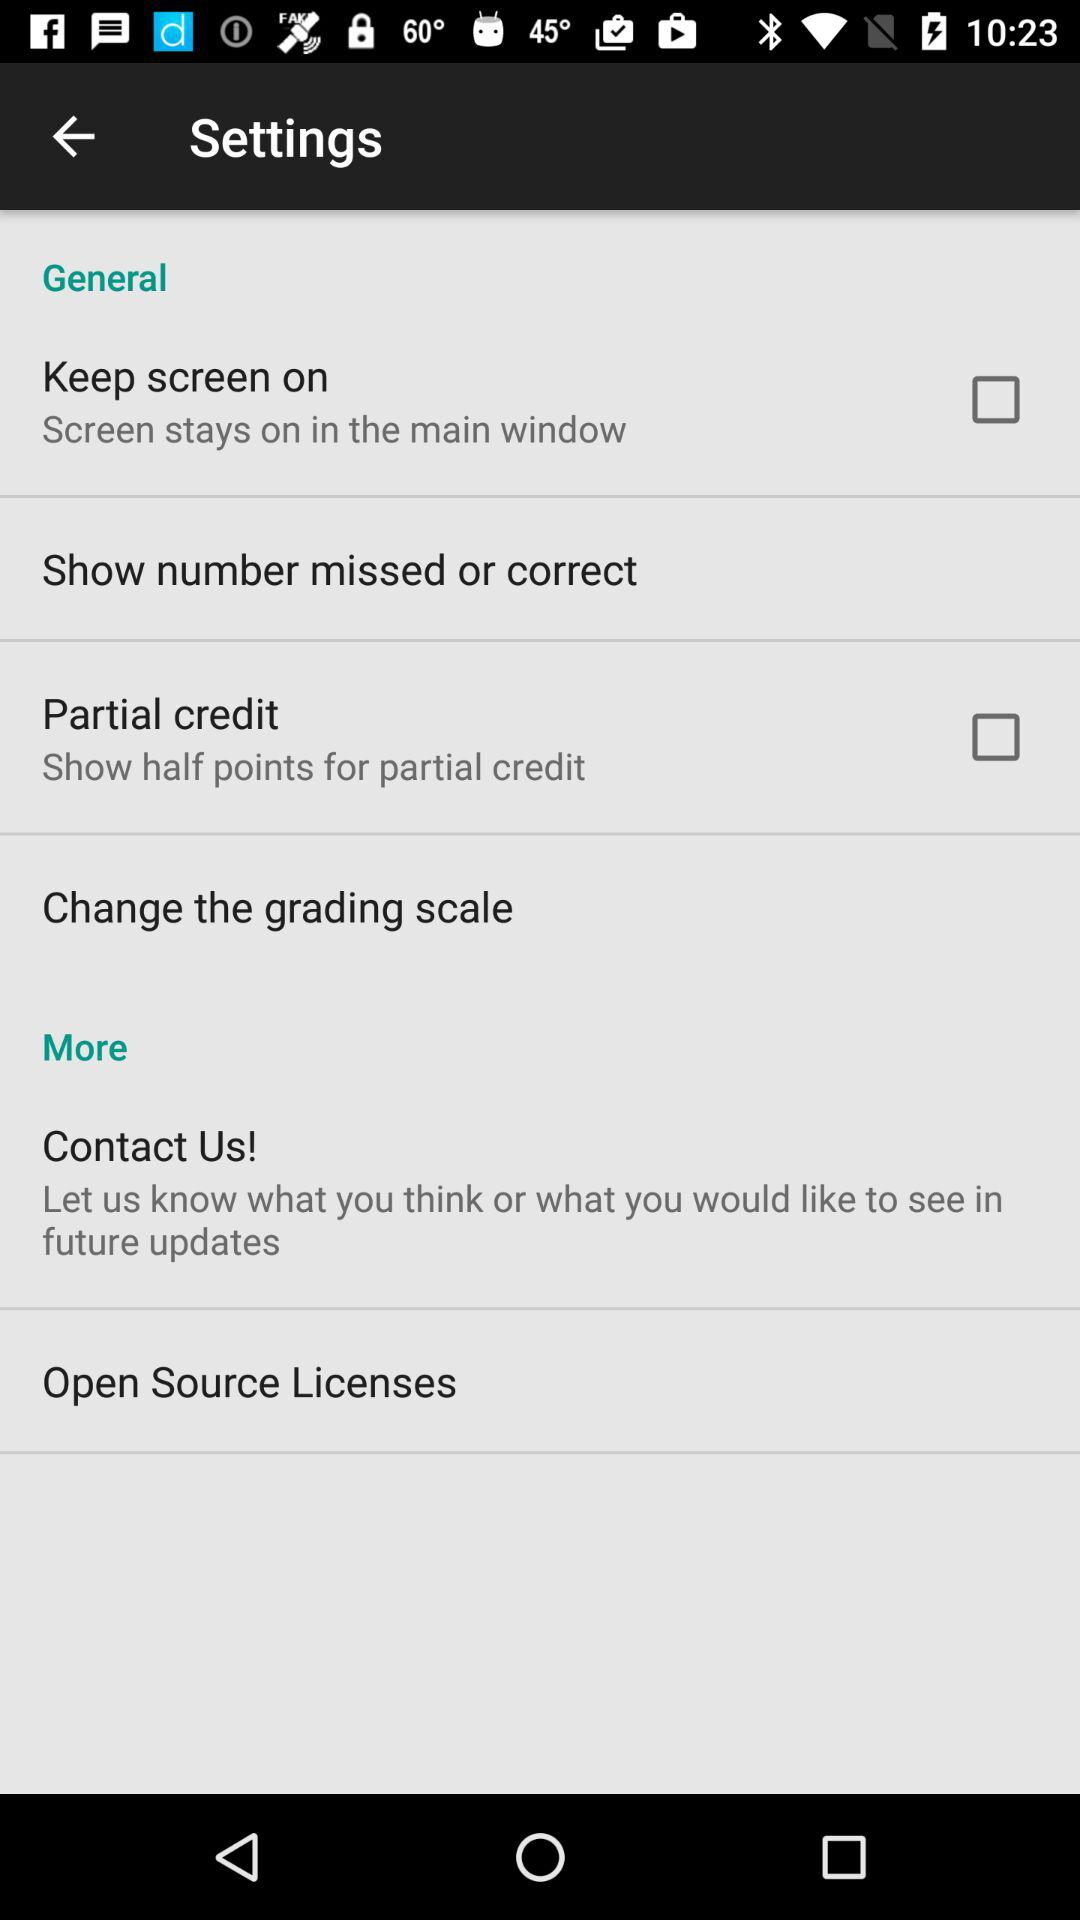What is the status of the "Partial credit"? The status is "off". 